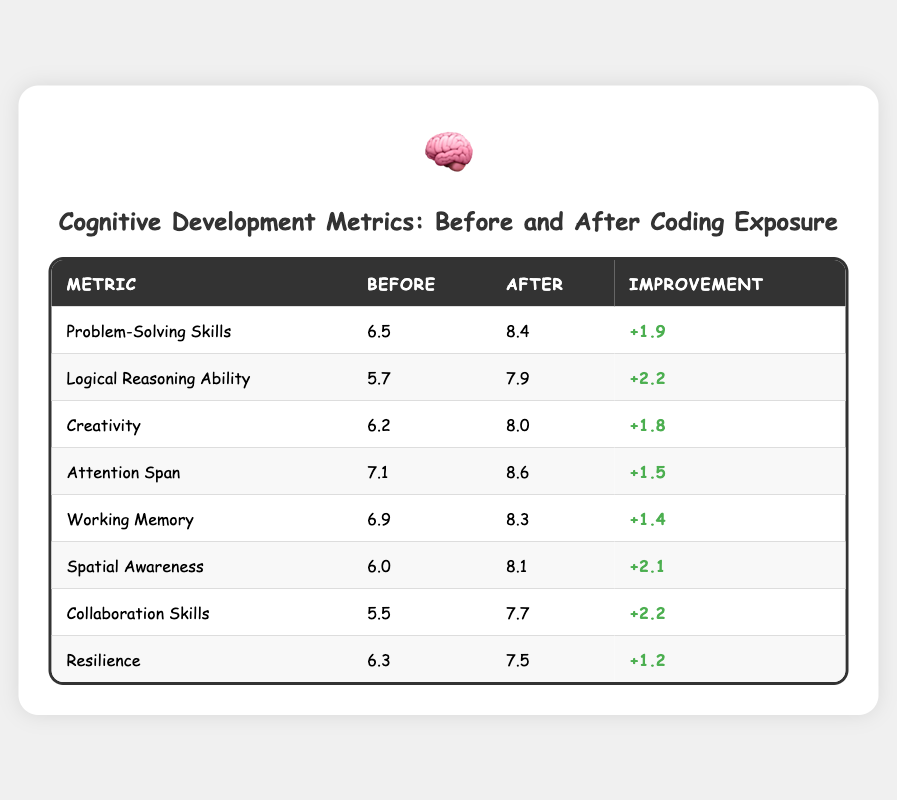What was the measure of Logical Reasoning Ability before coding exposure? The table shows that the measure of Logical Reasoning Ability before coding exposure was 5.7.
Answer: 5.7 What improvement was observed in Attention Span after coding exposure? The table lists the improvement in Attention Span as +1.5.
Answer: +1.5 Which cognitive development metric had the highest improvement? By comparing the improvements listed in the table, Logical Reasoning Ability and Collaboration Skills had the highest improvement of +2.2.
Answer: Logical Reasoning Ability and Collaboration Skills What is the measure of Spatial Awareness after coding exposure? The table indicates that the measure of Spatial Awareness after coding exposure is 8.1.
Answer: 8.1 What is the average improvement across all cognitive metrics listed? First, we sum all the improvements: (1.9 + 2.2 + 1.8 + 1.5 + 1.4 + 2.1 + 2.2 + 1.2) = 14.3. Since there are 8 metrics, we divide by 8: 14.3/8 = 1.7875. Rounded, the average improvement is approximately 1.79.
Answer: 1.79 Did Resilience show an improvement of more than 2 points? Looking at the table, Resilience showed an improvement of +1.2, which is less than 2 points.
Answer: No What was the total measure before coding exposure for all metrics combined? Adding the 'before' measures: (6.5 + 5.7 + 6.2 + 7.1 + 6.9 + 6.0 + 5.5 + 6.3) = 50.2.
Answer: 50.2 How much more improvement did Logical Reasoning Ability show compared to Resilience? The improvement for Logical Reasoning Ability is +2.2 and for Resilience is +1.2. The difference is 2.2 - 1.2 = 1.0.
Answer: 1.0 What is the measure of Creativity before coding exposure? According to the table, the measure of Creativity before coding exposure is 6.2.
Answer: 6.2 Is the improvement in Working Memory greater than the improvement in Attention Span? The improvements are +1.4 for Working Memory and +1.5 for Attention Span, so Working Memory's improvement is less.
Answer: No 